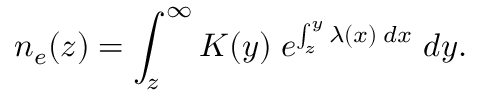Convert formula to latex. <formula><loc_0><loc_0><loc_500><loc_500>n _ { e } ( z ) = \int _ { z } ^ { \infty } K ( y ) \, e ^ { \int _ { z } ^ { y } \lambda ( x ) \, d x } \, d y .</formula> 